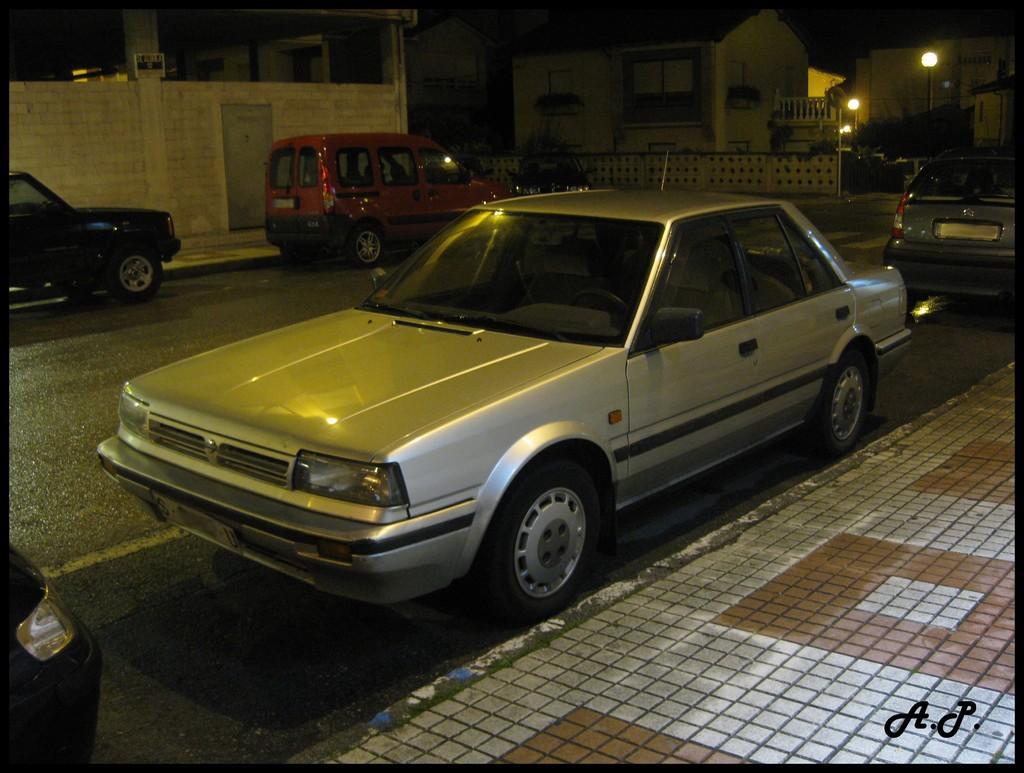How would you summarize this image in a sentence or two? This picture shows a few vehicles parked on both the sides of the road and we see buildings and couple of pole lights and we see sidewalk on both the sides. 